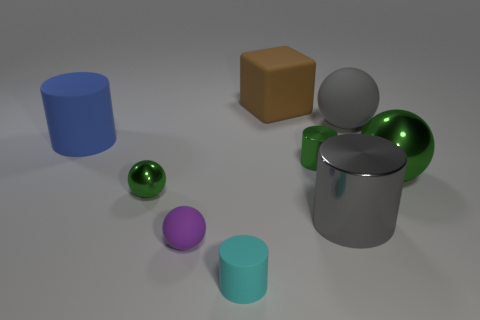Subtract all small cyan matte cylinders. How many cylinders are left? 3 Subtract all cyan cylinders. How many cylinders are left? 3 Subtract 2 cylinders. How many cylinders are left? 2 Subtract all blocks. How many objects are left? 8 Subtract all blue blocks. Subtract all yellow cylinders. How many blocks are left? 1 Subtract all red spheres. How many gray cylinders are left? 1 Subtract all large brown things. Subtract all large brown rubber cubes. How many objects are left? 7 Add 1 small things. How many small things are left? 5 Add 6 small gray rubber cubes. How many small gray rubber cubes exist? 6 Subtract 0 purple blocks. How many objects are left? 9 